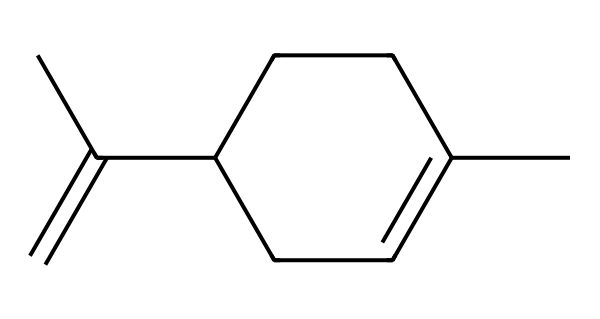How many carbon atoms are present in limonene? The SMILES representation indicates there are five carbon atoms in the cyclic part (C1=CCC) and two additional carbons in the side chain (CC), summing up to a total of eight carbon atoms.
Answer: eight What is the total number of double bonds in limonene? Analyzing the structure, there is one double bond between the two carbon atoms indicated by "C(=C)", which suggests there is only one double bond in the entire molecule.
Answer: one Is limonene a saturated or unsaturated compound? The presence of the double bond indicates that not all carbon-carbon bonds are single, which means limonene is classified as an unsaturated compound.
Answer: unsaturated How many rings does limonene have? Limonene features a single cyclic structure as indicated by the ring formed with carbon atoms in the SMILES notation, hence it has one ring.
Answer: one Does limonene contain any functional groups? Upon examining the SMILES, there are no distinctive functional groups such as hydroxyl or carboxyl; thus, the structure primarily consists of hydrogens and carbons.
Answer: no What type of chemical is limonene? Limonene is classified as a monoterpene, given its molecular structure and the fact that it contains ten carbon atoms in total when considering all carbons in the cyclic form and side chains.
Answer: monoterpene 